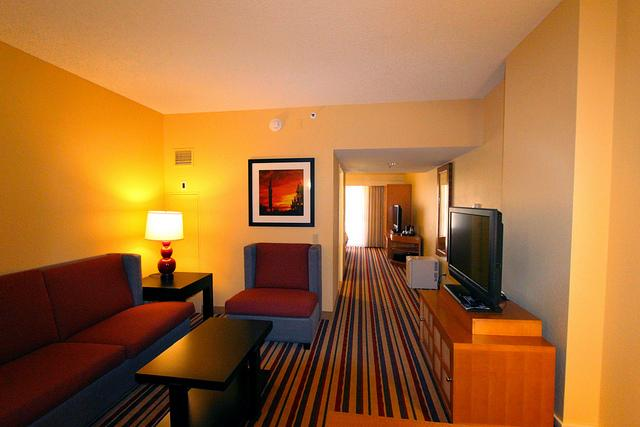What can be done with the appliance in this room? watch tv 